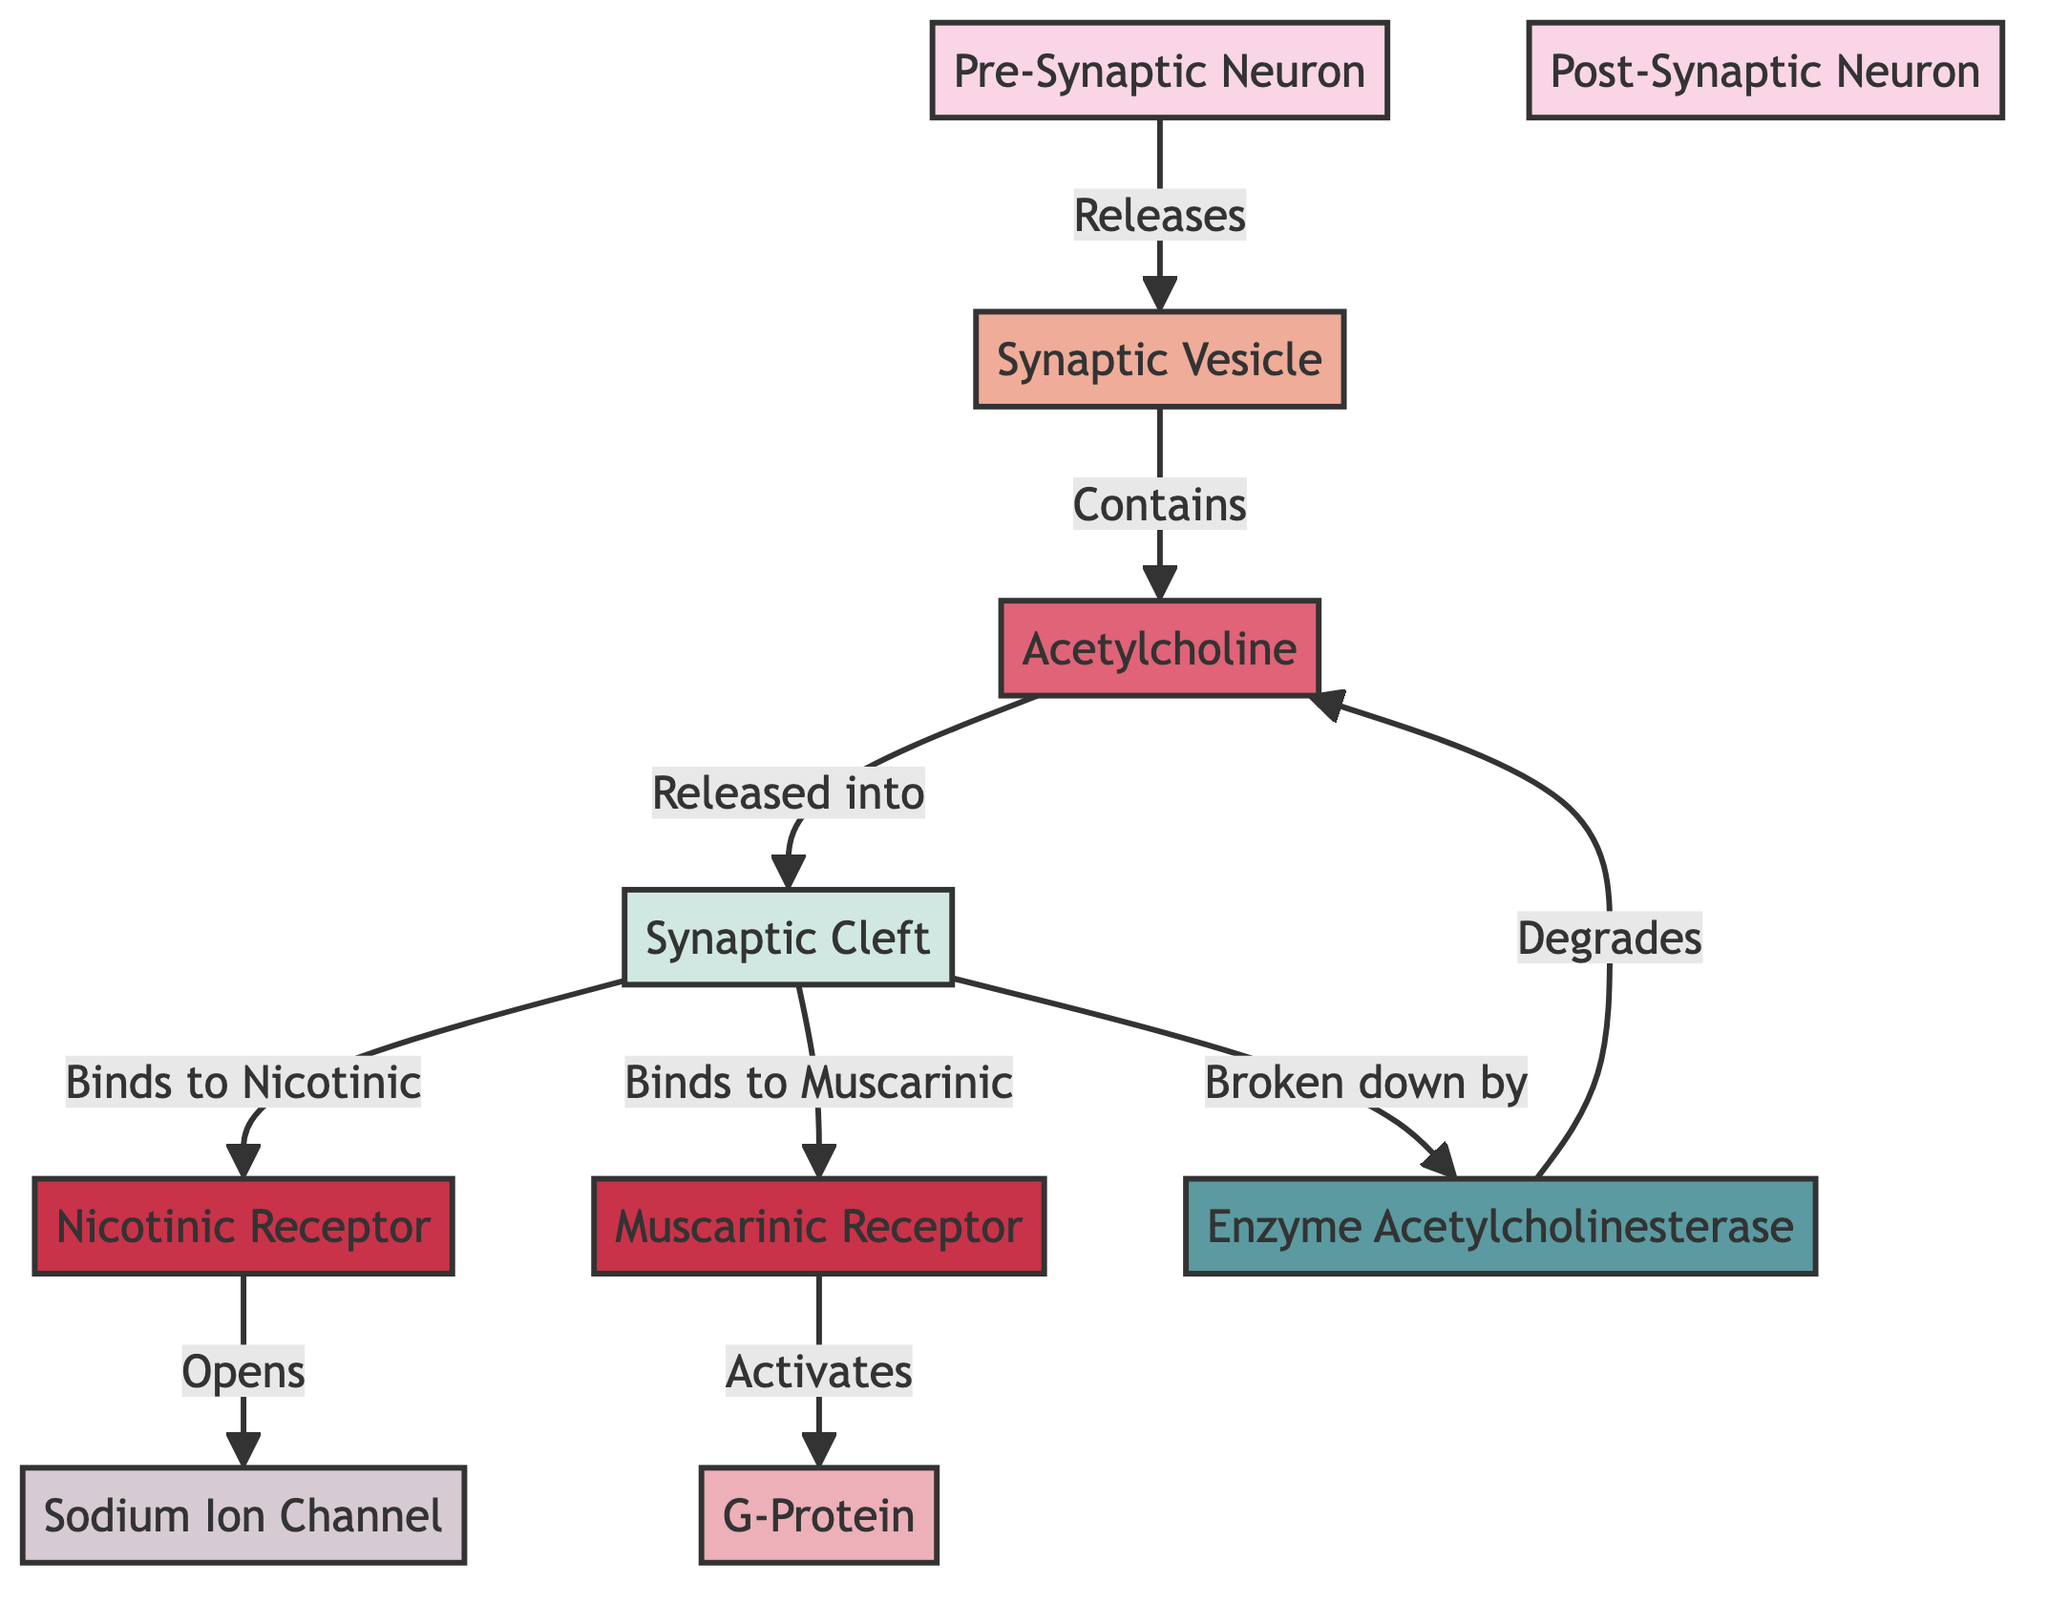What is the first node in the diagram? The first node listed in the diagram is "Pre-Synaptic Neuron." It is the starting point of the signal pathway and indicated as node 1.
Answer: Pre-Synaptic Neuron How many receptors are highlighted in the diagram? There are two receptors highlighted in the diagram: "Nicotinic Receptor" and "Muscarinic Receptor." Counting these nodes gives us a total of two.
Answer: 2 What substance is released into the synaptic cleft? The substance released into the synaptic cleft is "Acetylcholine." Node 3 is shown to be released into node 4.
Answer: Acetylcholine What enzyme breaks down acetylcholine? The enzyme that breaks down acetylcholine is "Acetylcholinesterase," indicated as node 10 in the diagram.
Answer: Acetylcholinesterase Which receptor opens the sodium ion channel? The "Nicotinic Receptor" is responsible for opening the sodium ion channel, as shown by the connection from node 6 to node 8.
Answer: Nicotinic Receptor What is the function of the G-Protein in the diagram? The G-Protein, represented as node 9, is activated by the "Muscarinic Receptor" and is part of the signaling cascade. It plays a role in transducing the signal further.
Answer: Activates the signaling pathway How many connections are there from the synaptic cleft? There are three connections leading away from the synaptic cleft (node 4): one going to the Nicotinic Receptor, one to the Muscarinic Receptor, and one to Acetylcholinesterase.
Answer: 3 What happens to acetylcholine after it is broken down? After acetylcholine is broken down by acetylcholinesterase, it is degraded. This is represented as node 10 degrading node 3.
Answer: Degrades What links the pre-synaptic neuron to the synaptic vesicle? The link from the pre-synaptic neuron (node 1) to the synaptic vesicle (node 2) is described as the pre-synaptic neuron releasing the synaptic vesicle.
Answer: Releases 